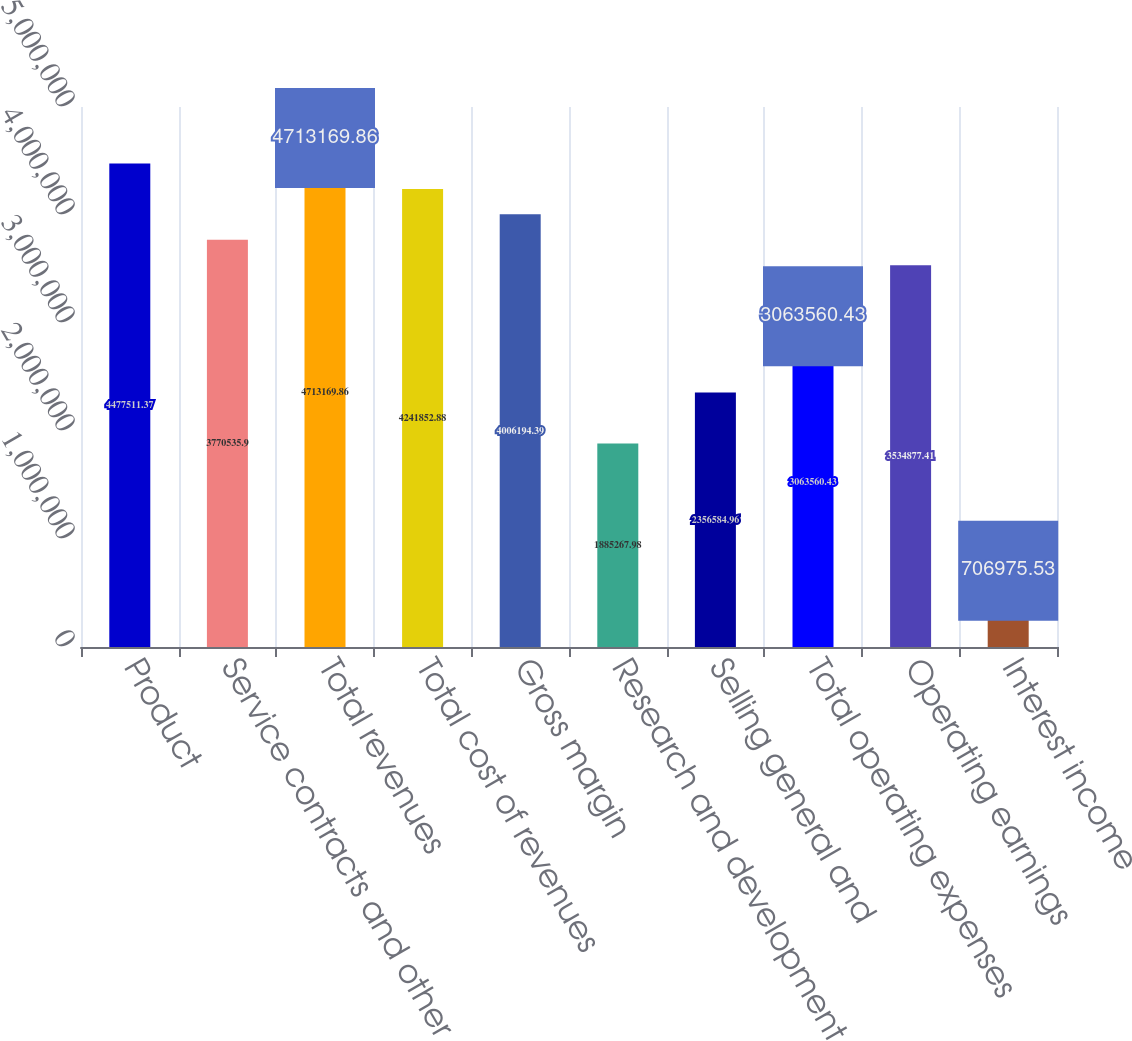<chart> <loc_0><loc_0><loc_500><loc_500><bar_chart><fcel>Product<fcel>Service contracts and other<fcel>Total revenues<fcel>Total cost of revenues<fcel>Gross margin<fcel>Research and development<fcel>Selling general and<fcel>Total operating expenses<fcel>Operating earnings<fcel>Interest income<nl><fcel>4.47751e+06<fcel>3.77054e+06<fcel>4.71317e+06<fcel>4.24185e+06<fcel>4.00619e+06<fcel>1.88527e+06<fcel>2.35658e+06<fcel>3.06356e+06<fcel>3.53488e+06<fcel>706976<nl></chart> 